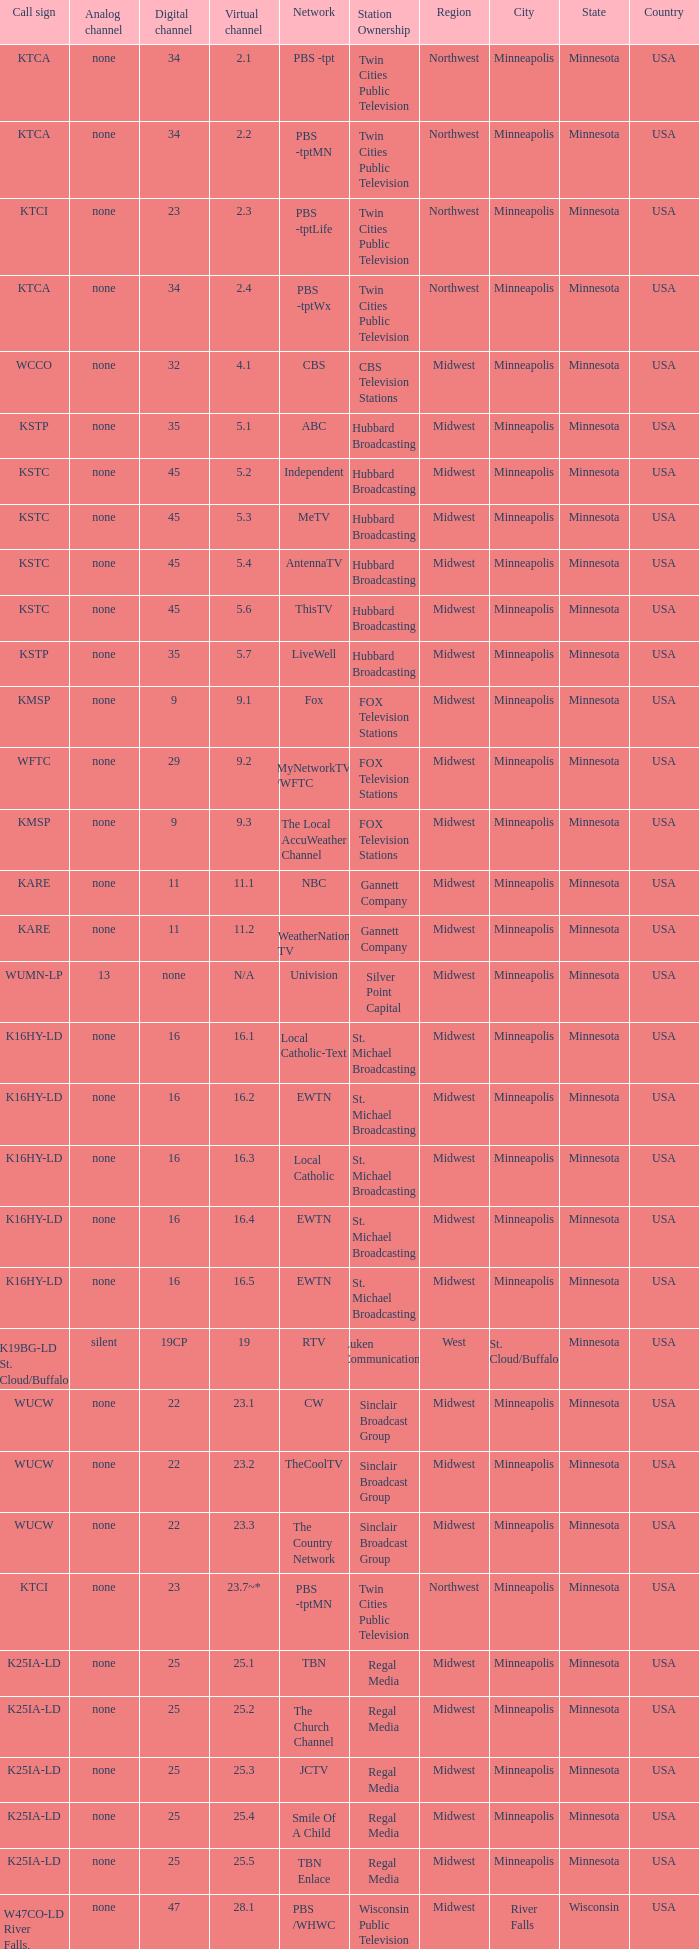Call sign of k43hb-ld is what virtual channel? 43.1. 